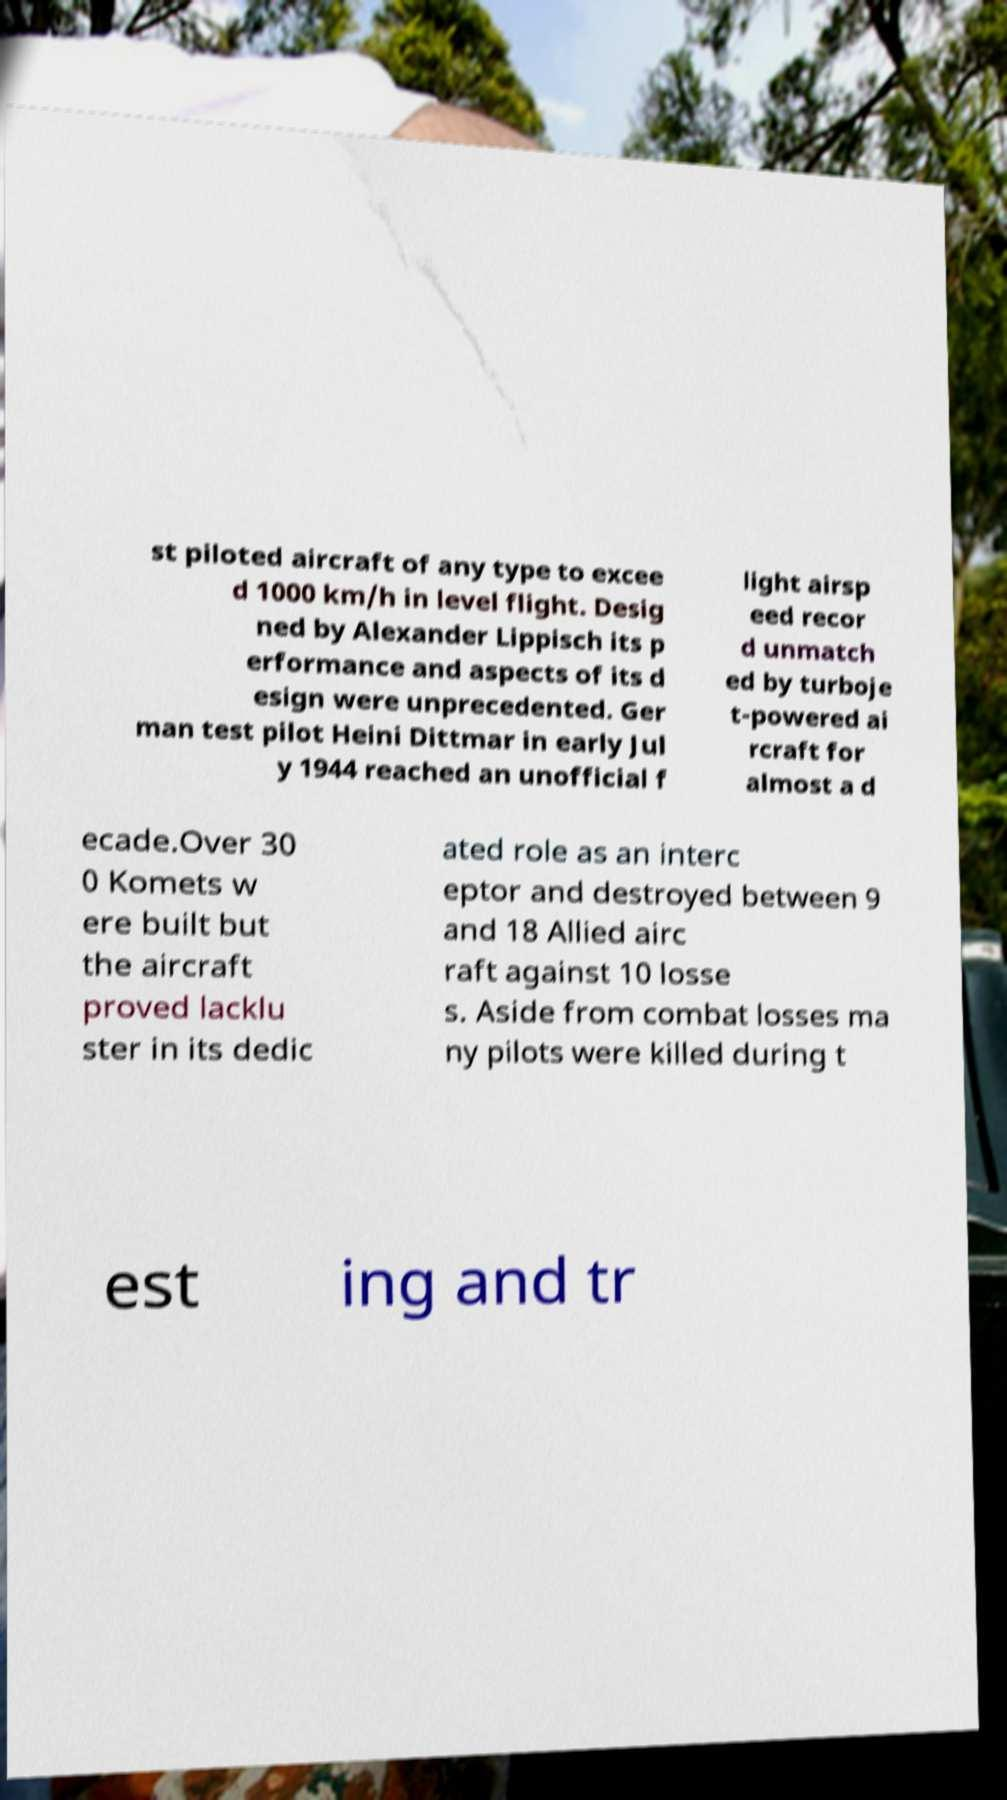Could you assist in decoding the text presented in this image and type it out clearly? st piloted aircraft of any type to excee d 1000 km/h in level flight. Desig ned by Alexander Lippisch its p erformance and aspects of its d esign were unprecedented. Ger man test pilot Heini Dittmar in early Jul y 1944 reached an unofficial f light airsp eed recor d unmatch ed by turboje t-powered ai rcraft for almost a d ecade.Over 30 0 Komets w ere built but the aircraft proved lacklu ster in its dedic ated role as an interc eptor and destroyed between 9 and 18 Allied airc raft against 10 losse s. Aside from combat losses ma ny pilots were killed during t est ing and tr 